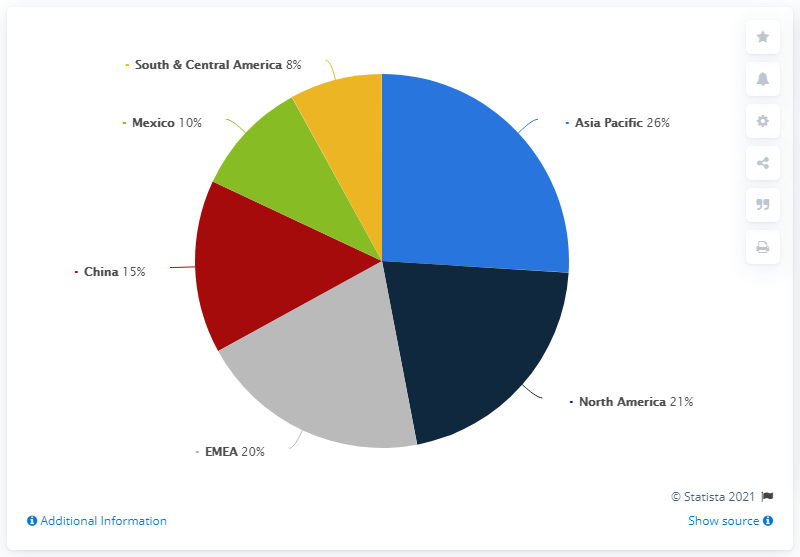Identify some key points in this picture. In 2019, Herbalife's net sales were primarily generated from the Asia Pacific region. In 2019, Herbalife's net sales in the Asia Pacific region accounted for the majority of the company's global net sales. Herbalife's net sales in South & Central America accounted for a very small percentage of the company's global net sales in 2019. 